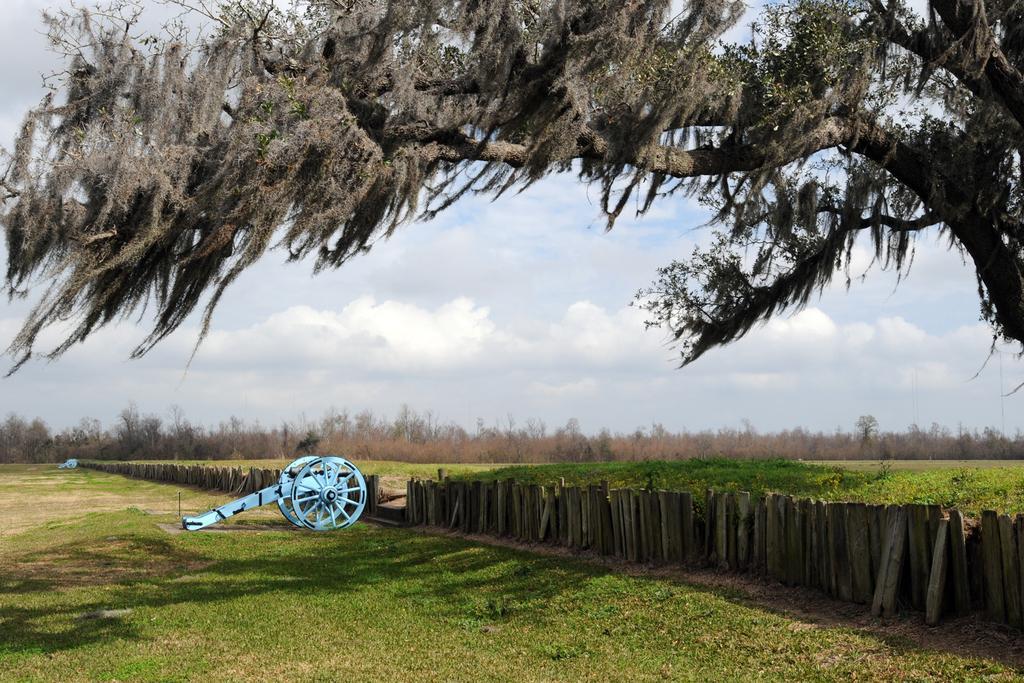How would you summarize this image in a sentence or two? In this image there is a wooden cart on the grass field behind that there is some wooden fence, grass ground and trees. 